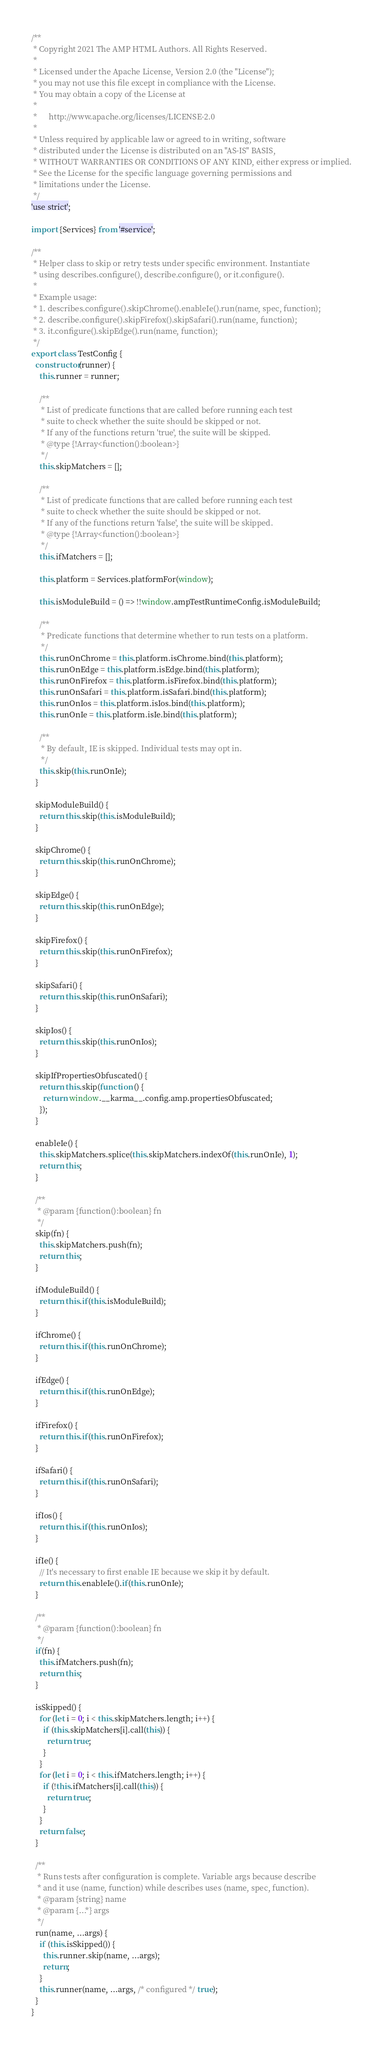<code> <loc_0><loc_0><loc_500><loc_500><_JavaScript_>/**
 * Copyright 2021 The AMP HTML Authors. All Rights Reserved.
 *
 * Licensed under the Apache License, Version 2.0 (the "License");
 * you may not use this file except in compliance with the License.
 * You may obtain a copy of the License at
 *
 *      http://www.apache.org/licenses/LICENSE-2.0
 *
 * Unless required by applicable law or agreed to in writing, software
 * distributed under the License is distributed on an "AS-IS" BASIS,
 * WITHOUT WARRANTIES OR CONDITIONS OF ANY KIND, either express or implied.
 * See the License for the specific language governing permissions and
 * limitations under the License.
 */
'use strict';

import {Services} from '#service';

/**
 * Helper class to skip or retry tests under specific environment. Instantiate
 * using describes.configure(), describe.configure(), or it.configure().
 *
 * Example usage:
 * 1. describes.configure().skipChrome().enableIe().run(name, spec, function);
 * 2. describe.configure().skipFirefox().skipSafari().run(name, function);
 * 3. it.configure().skipEdge().run(name, function);
 */
export class TestConfig {
  constructor(runner) {
    this.runner = runner;

    /**
     * List of predicate functions that are called before running each test
     * suite to check whether the suite should be skipped or not.
     * If any of the functions return 'true', the suite will be skipped.
     * @type {!Array<function():boolean>}
     */
    this.skipMatchers = [];

    /**
     * List of predicate functions that are called before running each test
     * suite to check whether the suite should be skipped or not.
     * If any of the functions return 'false', the suite will be skipped.
     * @type {!Array<function():boolean>}
     */
    this.ifMatchers = [];

    this.platform = Services.platformFor(window);

    this.isModuleBuild = () => !!window.ampTestRuntimeConfig.isModuleBuild;

    /**
     * Predicate functions that determine whether to run tests on a platform.
     */
    this.runOnChrome = this.platform.isChrome.bind(this.platform);
    this.runOnEdge = this.platform.isEdge.bind(this.platform);
    this.runOnFirefox = this.platform.isFirefox.bind(this.platform);
    this.runOnSafari = this.platform.isSafari.bind(this.platform);
    this.runOnIos = this.platform.isIos.bind(this.platform);
    this.runOnIe = this.platform.isIe.bind(this.platform);

    /**
     * By default, IE is skipped. Individual tests may opt in.
     */
    this.skip(this.runOnIe);
  }

  skipModuleBuild() {
    return this.skip(this.isModuleBuild);
  }

  skipChrome() {
    return this.skip(this.runOnChrome);
  }

  skipEdge() {
    return this.skip(this.runOnEdge);
  }

  skipFirefox() {
    return this.skip(this.runOnFirefox);
  }

  skipSafari() {
    return this.skip(this.runOnSafari);
  }

  skipIos() {
    return this.skip(this.runOnIos);
  }

  skipIfPropertiesObfuscated() {
    return this.skip(function () {
      return window.__karma__.config.amp.propertiesObfuscated;
    });
  }

  enableIe() {
    this.skipMatchers.splice(this.skipMatchers.indexOf(this.runOnIe), 1);
    return this;
  }

  /**
   * @param {function():boolean} fn
   */
  skip(fn) {
    this.skipMatchers.push(fn);
    return this;
  }

  ifModuleBuild() {
    return this.if(this.isModuleBuild);
  }

  ifChrome() {
    return this.if(this.runOnChrome);
  }

  ifEdge() {
    return this.if(this.runOnEdge);
  }

  ifFirefox() {
    return this.if(this.runOnFirefox);
  }

  ifSafari() {
    return this.if(this.runOnSafari);
  }

  ifIos() {
    return this.if(this.runOnIos);
  }

  ifIe() {
    // It's necessary to first enable IE because we skip it by default.
    return this.enableIe().if(this.runOnIe);
  }

  /**
   * @param {function():boolean} fn
   */
  if(fn) {
    this.ifMatchers.push(fn);
    return this;
  }

  isSkipped() {
    for (let i = 0; i < this.skipMatchers.length; i++) {
      if (this.skipMatchers[i].call(this)) {
        return true;
      }
    }
    for (let i = 0; i < this.ifMatchers.length; i++) {
      if (!this.ifMatchers[i].call(this)) {
        return true;
      }
    }
    return false;
  }

  /**
   * Runs tests after configuration is complete. Variable args because describe
   * and it use (name, function) while describes uses (name, spec, function).
   * @param {string} name
   * @param {...*} args
   */
  run(name, ...args) {
    if (this.isSkipped()) {
      this.runner.skip(name, ...args);
      return;
    }
    this.runner(name, ...args, /* configured */ true);
  }
}
</code> 